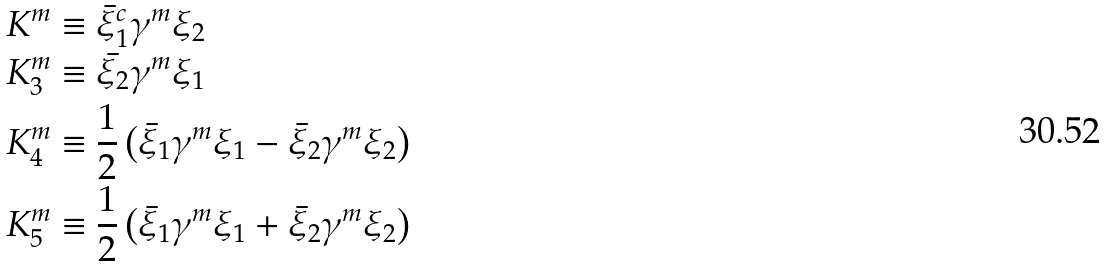Convert formula to latex. <formula><loc_0><loc_0><loc_500><loc_500>K ^ { m } & \equiv \bar { \xi } _ { 1 } ^ { c } \gamma ^ { m } \xi _ { 2 } \\ K ^ { m } _ { 3 } & \equiv \bar { \xi _ { 2 } } \gamma ^ { m } \xi _ { 1 } \\ K ^ { m } _ { 4 } & \equiv \frac { 1 } { 2 } \left ( \bar { \xi } _ { 1 } \gamma ^ { m } \xi _ { 1 } - \bar { \xi } _ { 2 } \gamma ^ { m } \xi _ { 2 } \right ) \\ K ^ { m } _ { 5 } & \equiv \frac { 1 } { 2 } \left ( \bar { \xi } _ { 1 } \gamma ^ { m } \xi _ { 1 } + \bar { \xi } _ { 2 } \gamma ^ { m } \xi _ { 2 } \right )</formula> 